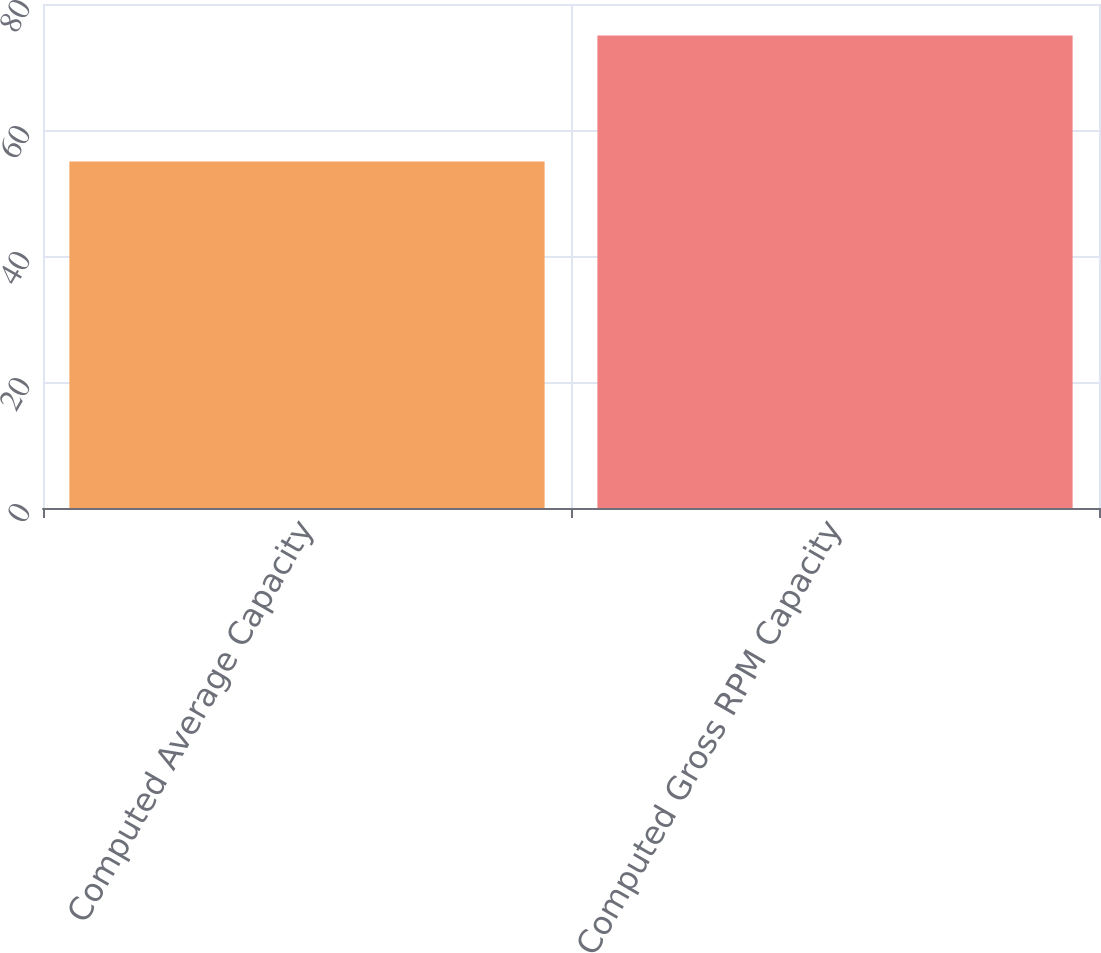<chart> <loc_0><loc_0><loc_500><loc_500><bar_chart><fcel>Computed Average Capacity<fcel>Computed Gross RPM Capacity<nl><fcel>55<fcel>75<nl></chart> 